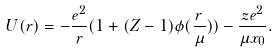<formula> <loc_0><loc_0><loc_500><loc_500>U ( r ) = - \frac { e ^ { 2 } } { r } ( 1 + ( Z - 1 ) \phi ( \frac { r } { \mu } ) ) - \frac { z e ^ { 2 } } { \mu x _ { 0 } } .</formula> 